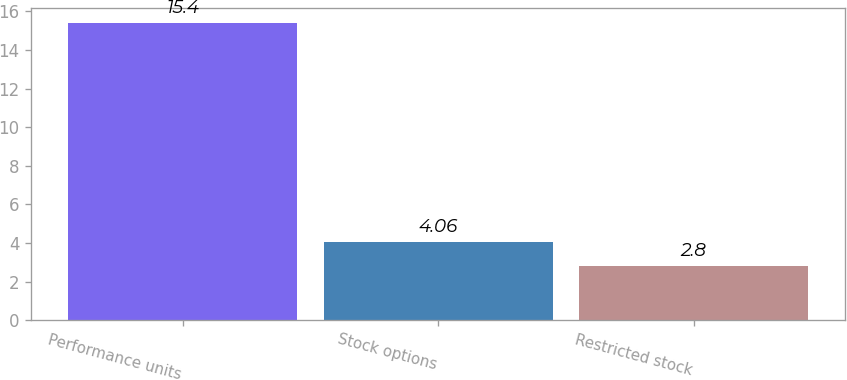Convert chart. <chart><loc_0><loc_0><loc_500><loc_500><bar_chart><fcel>Performance units<fcel>Stock options<fcel>Restricted stock<nl><fcel>15.4<fcel>4.06<fcel>2.8<nl></chart> 